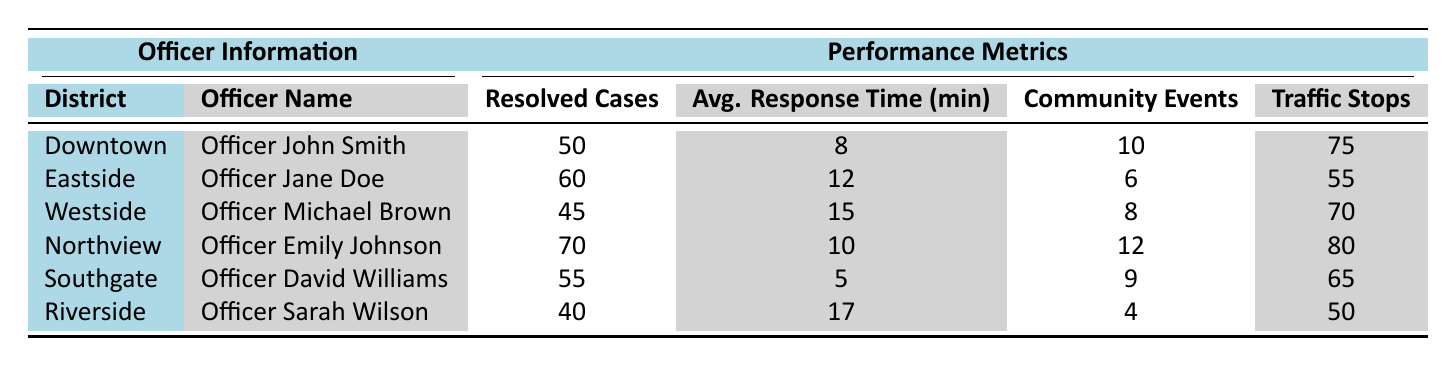What is the average response time for Officer Jane Doe? The average response time for Officer Jane Doe is listed in the "Avg. Response Time (min)" column for the Eastside district, which shows 12 minutes.
Answer: 12 minutes Which officer resolved the most cases? By comparing the "Resolved Cases" column, Officer Emily Johnson from Northview resolved the most cases, totaling 70.
Answer: Officer Emily Johnson Is the average response time for Southgate quicker than that of Riverside? Yes, the average response time for Southgate is 5 minutes, while Riverside's average is 17 minutes. Therefore, Southgate's response time is quicker.
Answer: Yes How many community engagement events did Officer Michael Brown participate in? The number of community engagement events for Officer Michael Brown, as indicated in the table, is 8 in the Westside district.
Answer: 8 events What is the total number of resolved cases for all officers? To find the total resolved cases, sum the "Resolved Cases" column: 50 (Downtown) + 60 (Eastside) + 45 (Westside) + 70 (Northview) + 55 (Southgate) + 40 (Riverside) = 320.
Answer: 320 cases Which officer has the highest average response time and what is it? Officer Sarah Wilson in Riverside has the highest average response time of 17 minutes, as seen in the "Avg. Response Time (min)" column.
Answer: 17 minutes If we compare the traffic stops of Northview and Southgate, who conducted more? Officer Emily Johnson in Northview conducted 80 traffic stops while Officer David Williams in Southgate conducted 65 stops. Therefore, Northview conducted more.
Answer: Northview (80 stops) What is the difference in average response time between the quickest and slowest officer? The quickest average response time is 5 minutes (Southgate) and the slowest is 17 minutes (Riverside). The difference is 17 - 5 = 12 minutes.
Answer: 12 minutes How many community engagement events did officers from Downtown and Eastside participate in combined? Combine the events from Downtown (10) and Eastside (6): 10 + 6 = 16 community events.
Answer: 16 events Which district has the lowest number of resolved cases? Riverside has the lowest number of resolved cases at 40, as seen in the "Resolved Cases" column.
Answer: Riverside 